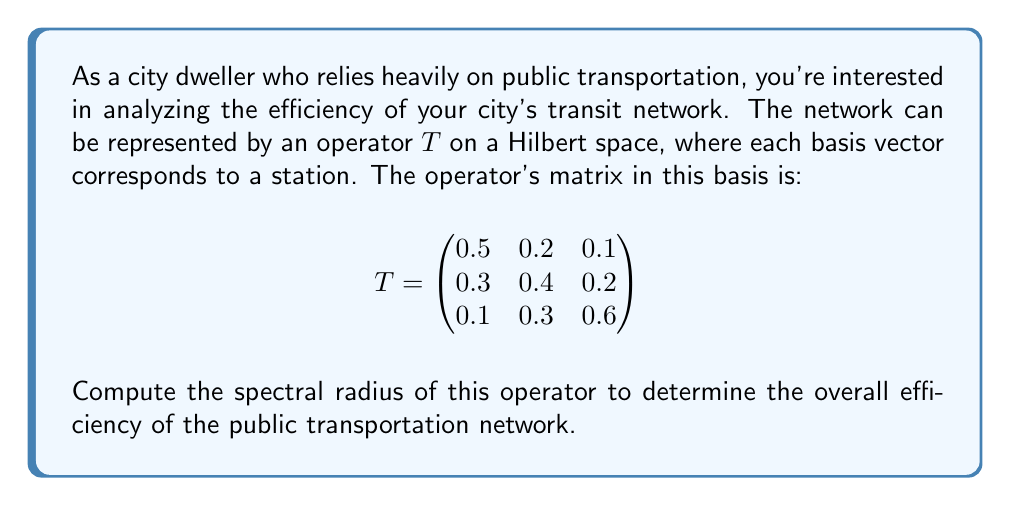Help me with this question. To compute the spectral radius of the operator $T$, we need to follow these steps:

1) The spectral radius $\rho(T)$ is defined as:
   $$\rho(T) = \max\{|\lambda| : \lambda \text{ is an eigenvalue of } T\}$$

2) To find the eigenvalues, we need to solve the characteristic equation:
   $$\det(T - \lambda I) = 0$$

3) Expanding the determinant:
   $$\begin{vmatrix}
   0.5-\lambda & 0.2 & 0.1 \\
   0.3 & 0.4-\lambda & 0.2 \\
   0.1 & 0.3 & 0.6-\lambda
   \end{vmatrix} = 0$$

4) This yields the characteristic polynomial:
   $$-\lambda^3 + 1.5\lambda^2 - 0.61\lambda + 0.078 = 0$$

5) Solving this equation (using a numerical method or computer algebra system) gives us the eigenvalues:
   $$\lambda_1 \approx 0.8992, \lambda_2 \approx 0.3604, \lambda_3 \approx 0.2404$$

6) The spectral radius is the maximum absolute value of these eigenvalues:
   $$\rho(T) = \max\{|0.8992|, |0.3604|, |0.2404|\} = 0.8992$$

This value represents the long-term behavior of the network's efficiency. A spectral radius close to 1 indicates a relatively efficient system, as it suggests that the network maintains its structure and connectivity over time.
Answer: $\rho(T) \approx 0.8992$ 